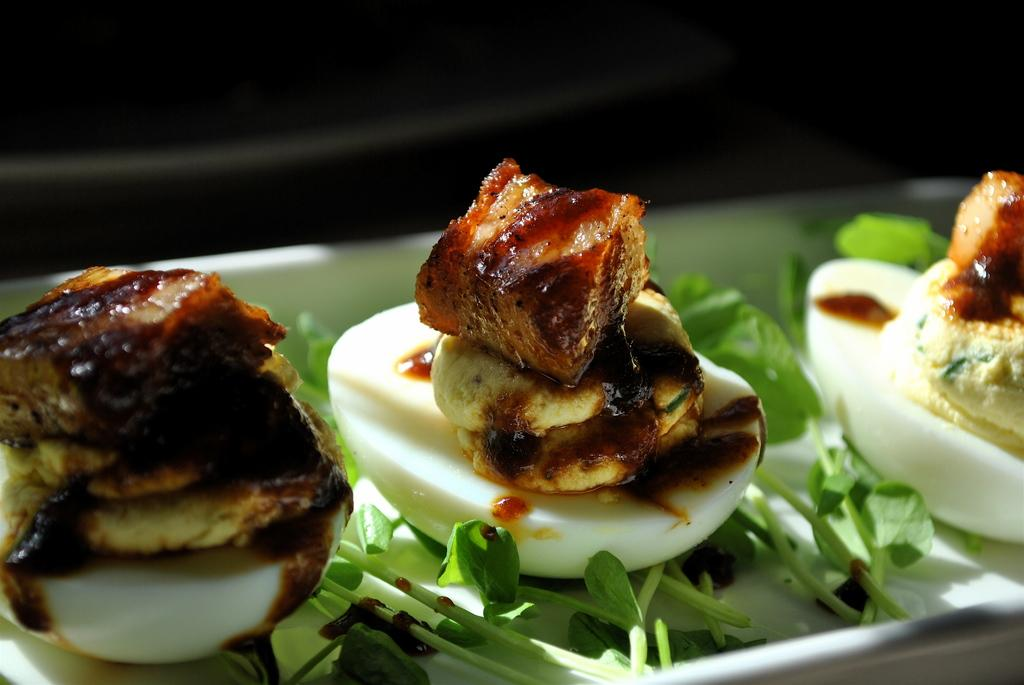What object is present in the image that might be used for serving food? There is a plate in the image. What is on the plate in the image? The plate contains leaves and food. How many cards are being used to organize the rabbits in the image? There are no cards or rabbits present in the image. 